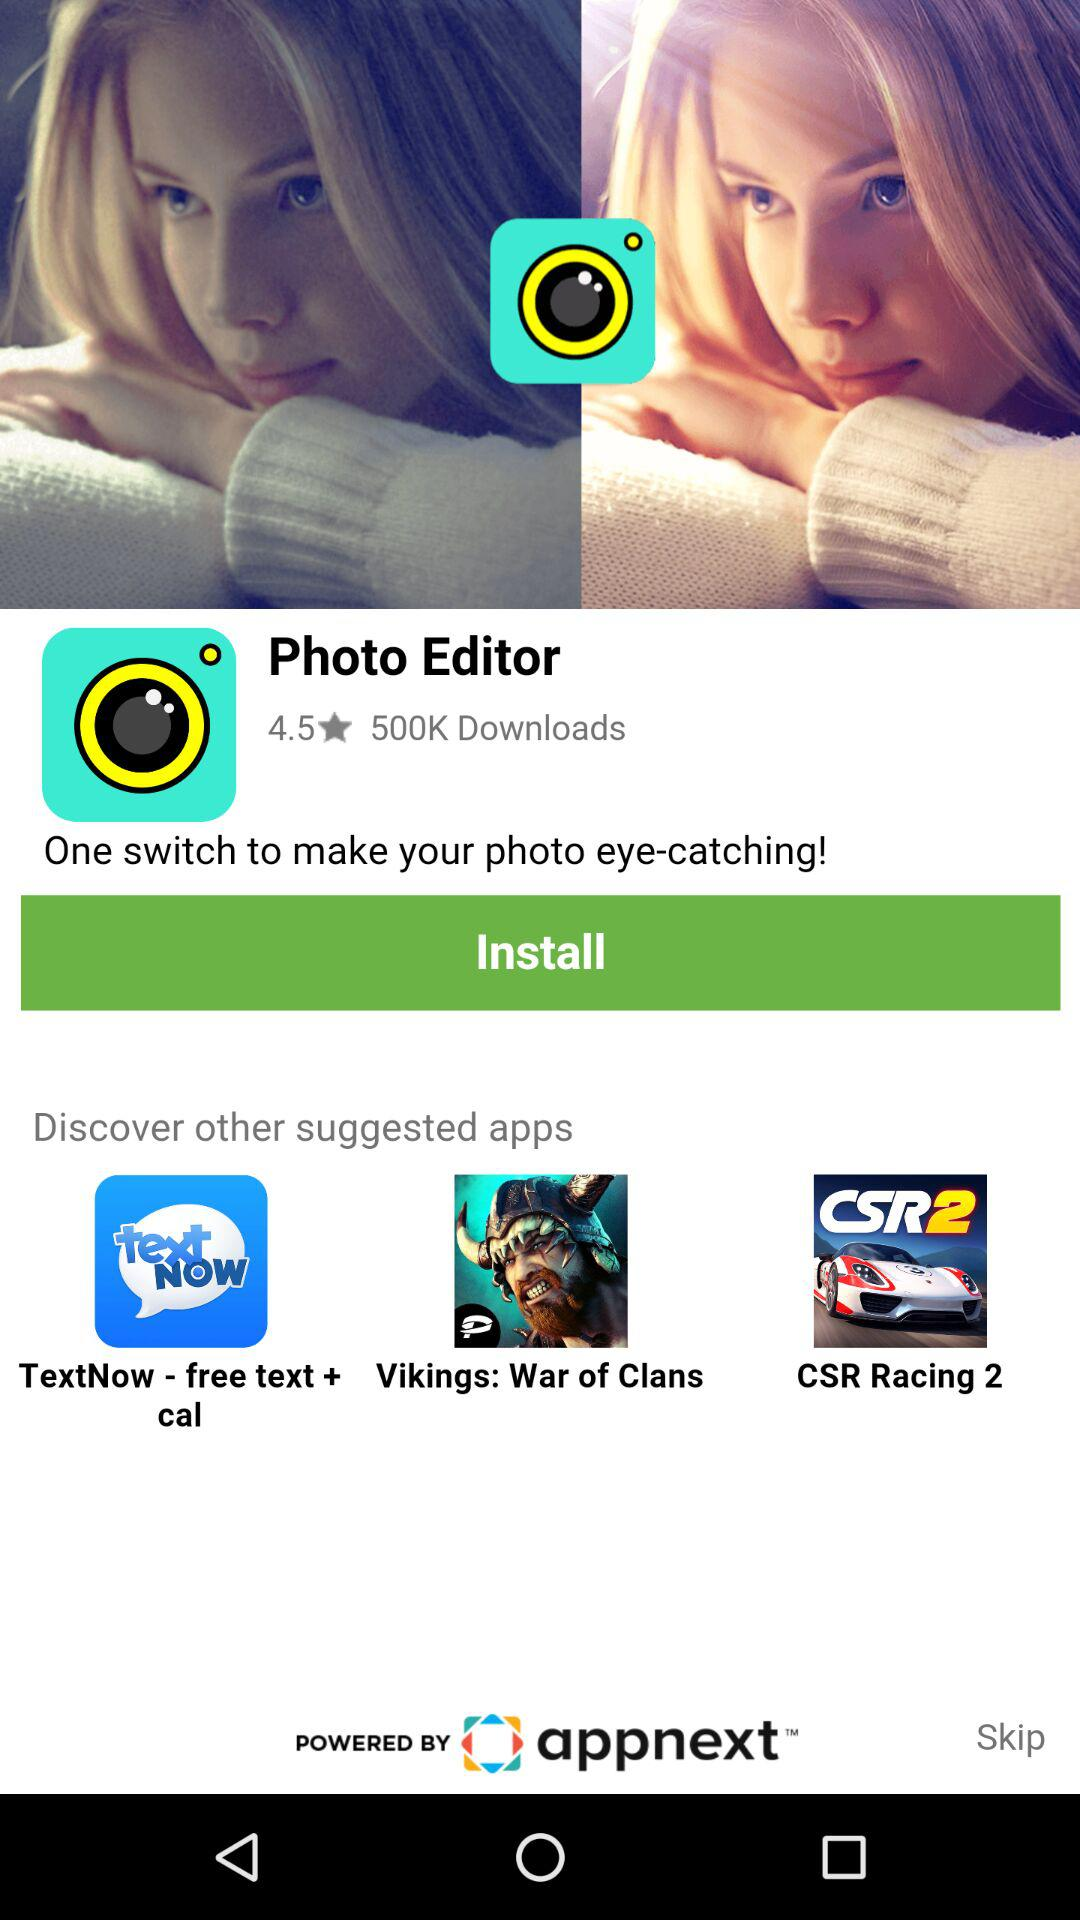How many downloads are there? There are 500K downloads. 